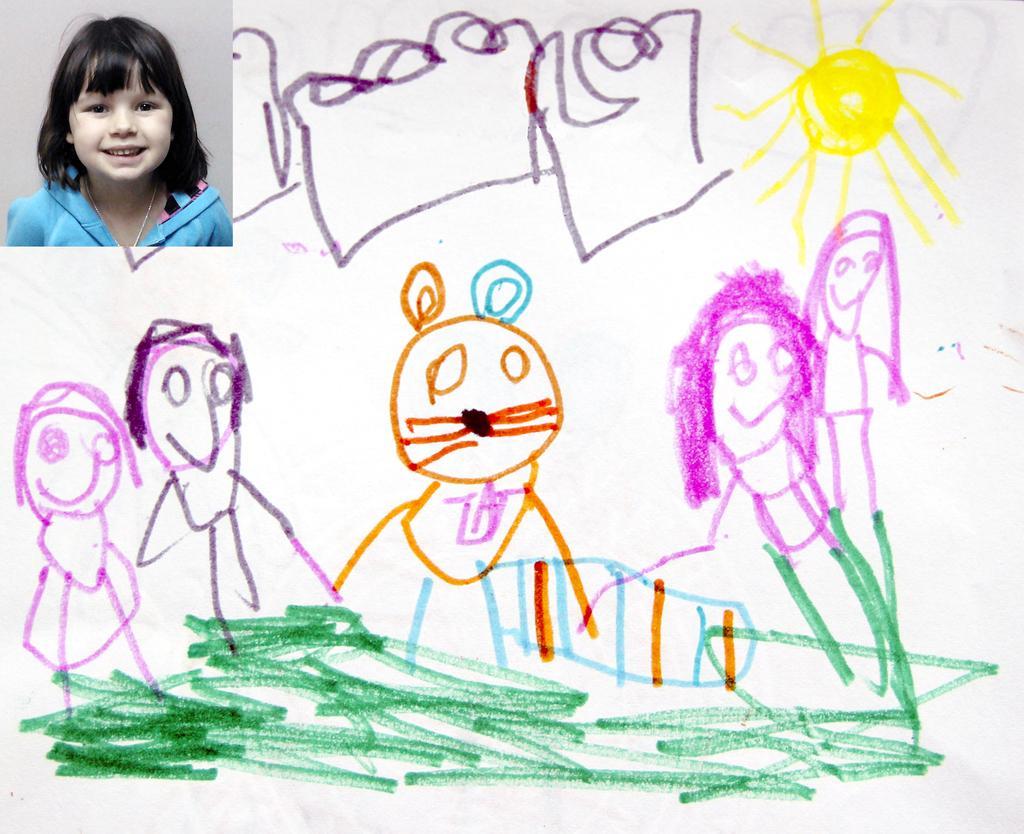How would you summarize this image in a sentence or two? In this picture we can see a paper, there is a picture of a kid at the left top of the picture, we can see drawing on this paper. 